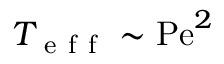<formula> <loc_0><loc_0><loc_500><loc_500>T _ { e f f } \sim P e ^ { 2 }</formula> 